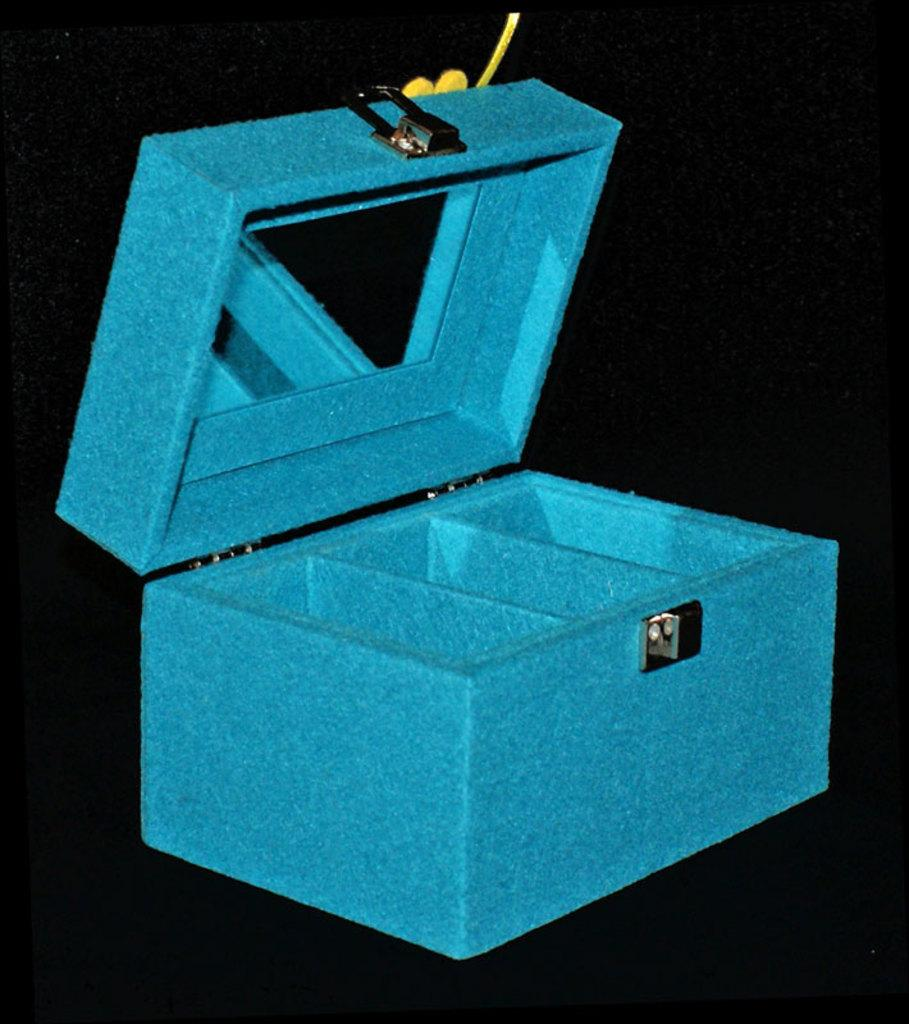What object is present in the image? There is a box in the image. What color is the box? The box is blue in color. What can be seen in the background of the image? The background of the image is black. How many bells are hanging from the box in the image? There are no bells present in the image; it only features a blue box against a black background. 